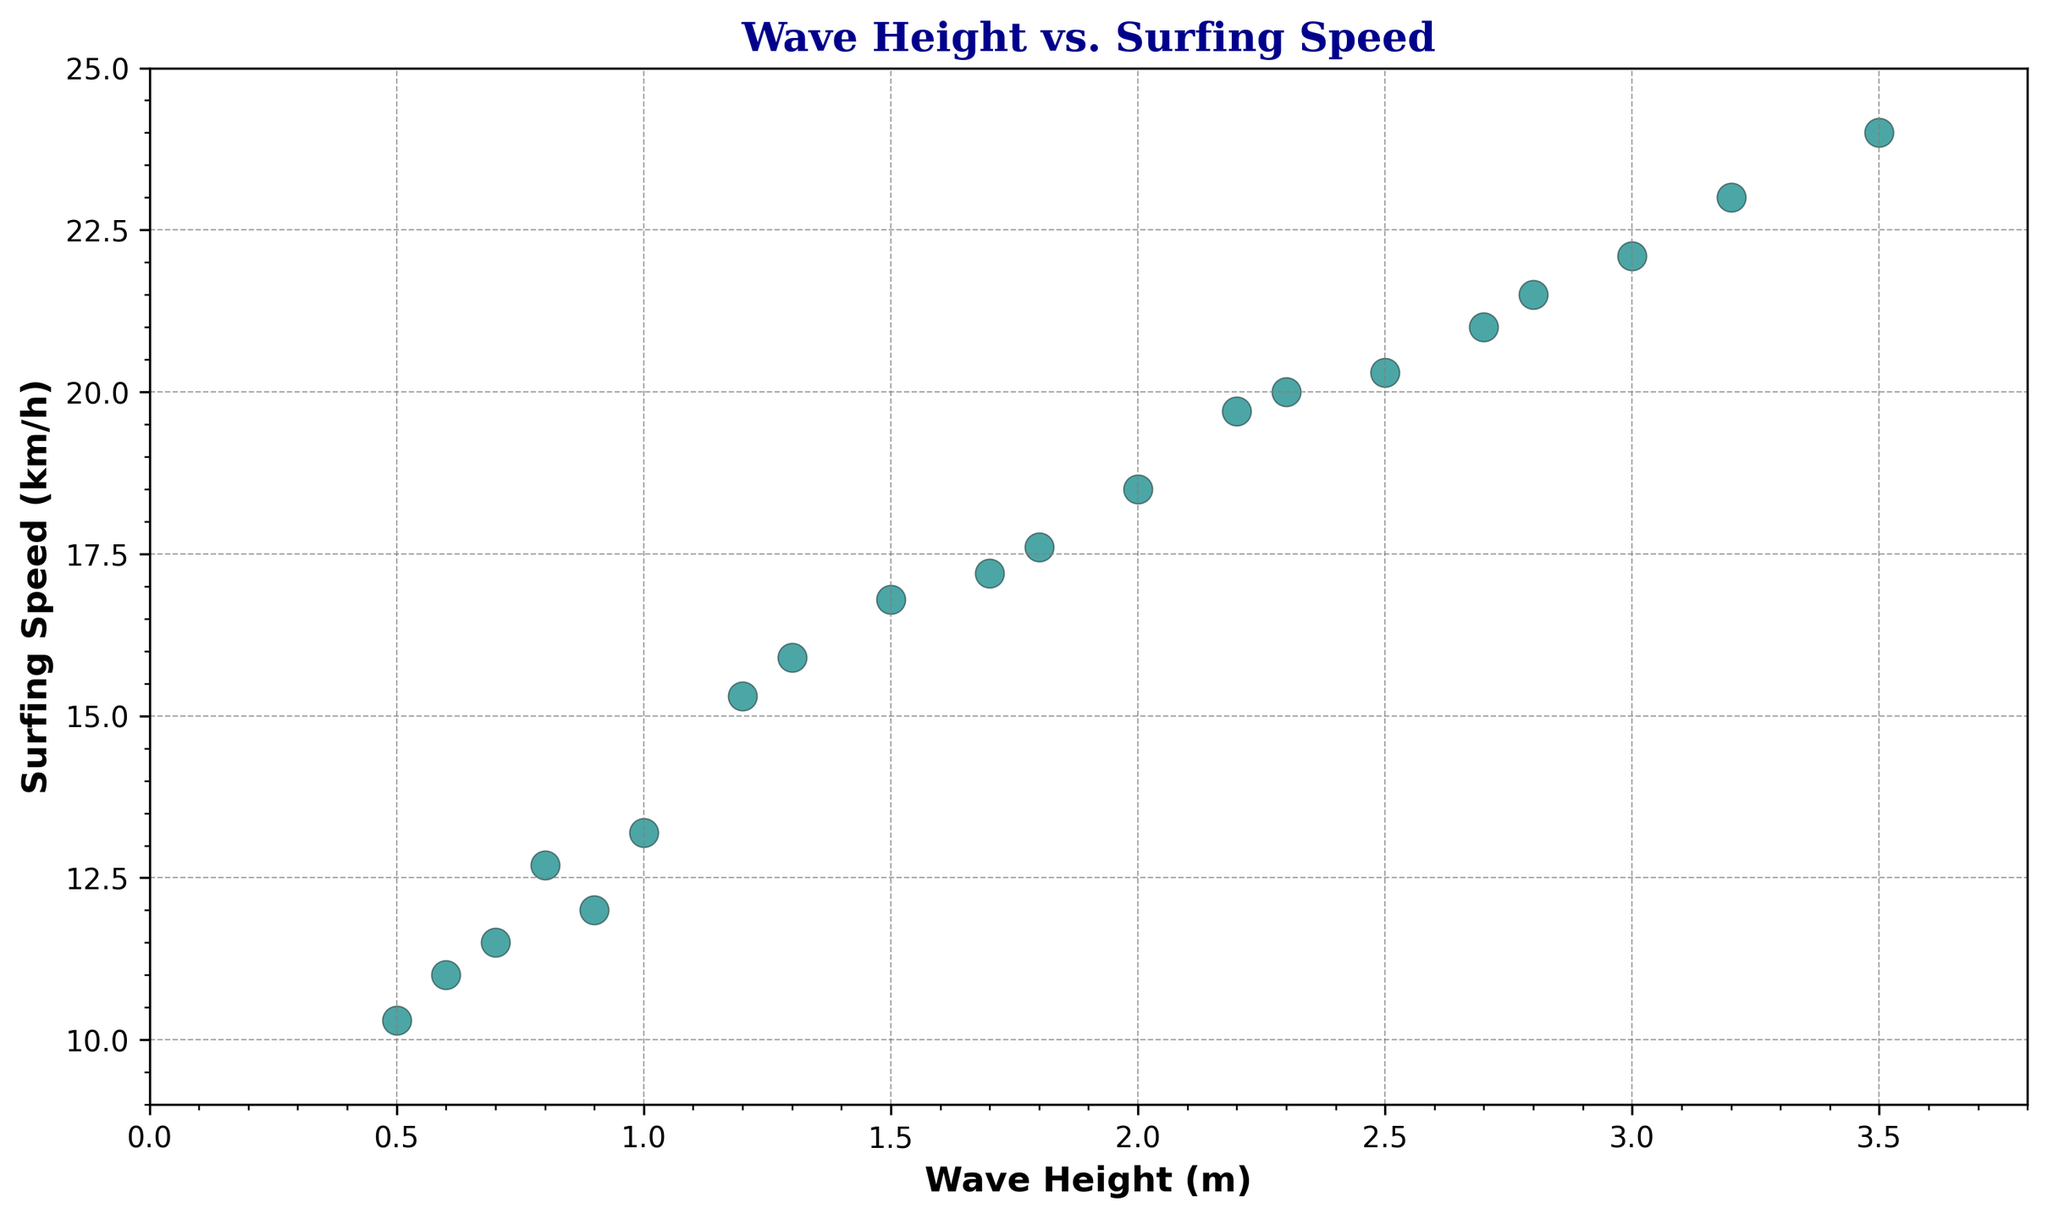What is the highest surfing speed recorded in the plot? To find the highest surfing speed, look for the highest point on the 'Surfing Speed (km/h)' axis. This corresponds to 24.0 km/h.
Answer: 24.0 km/h What wave height corresponds to the highest surfing speed? Locate the highest point on the 'Surfing Speed (km/h)' axis, then trace horizontally to find its wave height on the 'Wave Height (m)' axis. This corresponds to a wave height of 3.5 meters.
Answer: 3.5 m How does the surfing speed change as the wave height increases from 1.0 m to 2.0 m? Identify the points where the wave height is 1.0 m and 2.0 m. The respective surfing speeds are 13.2 km/h and 18.5 km/h, showing an increase in speed.
Answer: Increases from 13.2 km/h to 18.5 km/h What is the average surfing speed for waves of height 2.0 meters or more? Identify and sum the surfing speeds for wave heights 2.0, 2.5, 2.2, 3.0, 3.5, 2.8, 3.2, 2.3, and 2.7 meters: (18.5 + 20.3 + 19.7 + 22.1 + 24.0 + 21.5 + 23.0 + 20.0 + 21.0) = 170.1. There are 9 data points, so the average is 170.1/9 = 18.9 km/h.
Answer: 19.0 km/h Compare the surfing speed for wave heights of 1.5 m and 2.5 m. Which one is higher? Locate the points for wave heights 1.5 m and 2.5 m. The respective surfing speeds are 16.8 km/h and 20.3 km/h, with 2.5 m having the higher speed.
Answer: 2.5 m What is the difference in surfing speed between the wave heights of 1.3 m and 1.7 m? Identify the surfing speeds for wave heights 1.3 m and 1.7 m. They are 15.9 km/h and 17.2 km/h, respectively. The difference is 17.2 - 15.9 = 1.3 km/h.
Answer: 1.3 km/h What pattern can be observed about the relationship between wave height and surfing speed? By observing the trend in the scatter plot, it is evident that as the wave height increases, the surfing speed tends to increase as well.
Answer: Speed increases with wave height What is the surfing speed when the wave height is at its lowest? Identify the point with the lowest wave height, which is 0.5 meters. The corresponding surfing speed is 10.3 km/h.
Answer: 10.3 km/h What is the range of surfing speeds for wave heights between 1.0 m and 2.0 m? Identify the data points within this range and find the minimum and maximum surfing speeds: 13.2 km/h (1.0 m), 12.7 km/h (0.8 m), 16.8 km/h (1.5 m), 18.5 km/h (2.0 m), 15.9 km/h (1.3 m), 11.5 km/h (0.7 m), 12.0 km/h (0.9 m), 15.3 km/h (1.2 m), 17.6 km/h (1.8 m), and 17.2 km/h (1.7 m). The range is from 11.5 km/h to 18.5 km/h.
Answer: 11.5 km/h to 18.5 km/h 